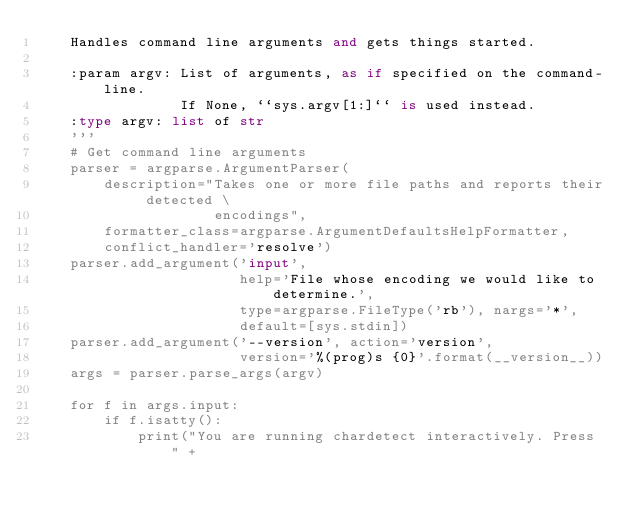Convert code to text. <code><loc_0><loc_0><loc_500><loc_500><_Python_>    Handles command line arguments and gets things started.

    :param argv: List of arguments, as if specified on the command-line.
                 If None, ``sys.argv[1:]`` is used instead.
    :type argv: list of str
    '''
    # Get command line arguments
    parser = argparse.ArgumentParser(
        description="Takes one or more file paths and reports their detected \
                     encodings",
        formatter_class=argparse.ArgumentDefaultsHelpFormatter,
        conflict_handler='resolve')
    parser.add_argument('input',
                        help='File whose encoding we would like to determine.',
                        type=argparse.FileType('rb'), nargs='*',
                        default=[sys.stdin])
    parser.add_argument('--version', action='version',
                        version='%(prog)s {0}'.format(__version__))
    args = parser.parse_args(argv)

    for f in args.input:
        if f.isatty():
            print("You are running chardetect interactively. Press " +</code> 